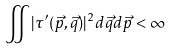<formula> <loc_0><loc_0><loc_500><loc_500>\iint | \tau ^ { \prime } ( \vec { p } , \vec { q } ) | ^ { 2 } d \vec { q } d \vec { p } < \infty</formula> 